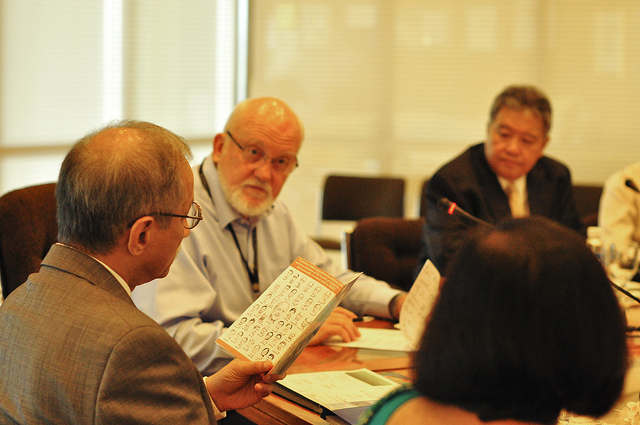<image>What is the woman's occupation? I don't know what the woman's occupation is. It could be a secretary, manager, businesswoman, attorney, doctor, office staff or CEO. What is the woman's occupation? I am not sure what the woman's occupation is. It can be 'secretary', 'manager', 'businesswoman', 'attorney', 'doctor', 'office staff', or 'ceo'. 